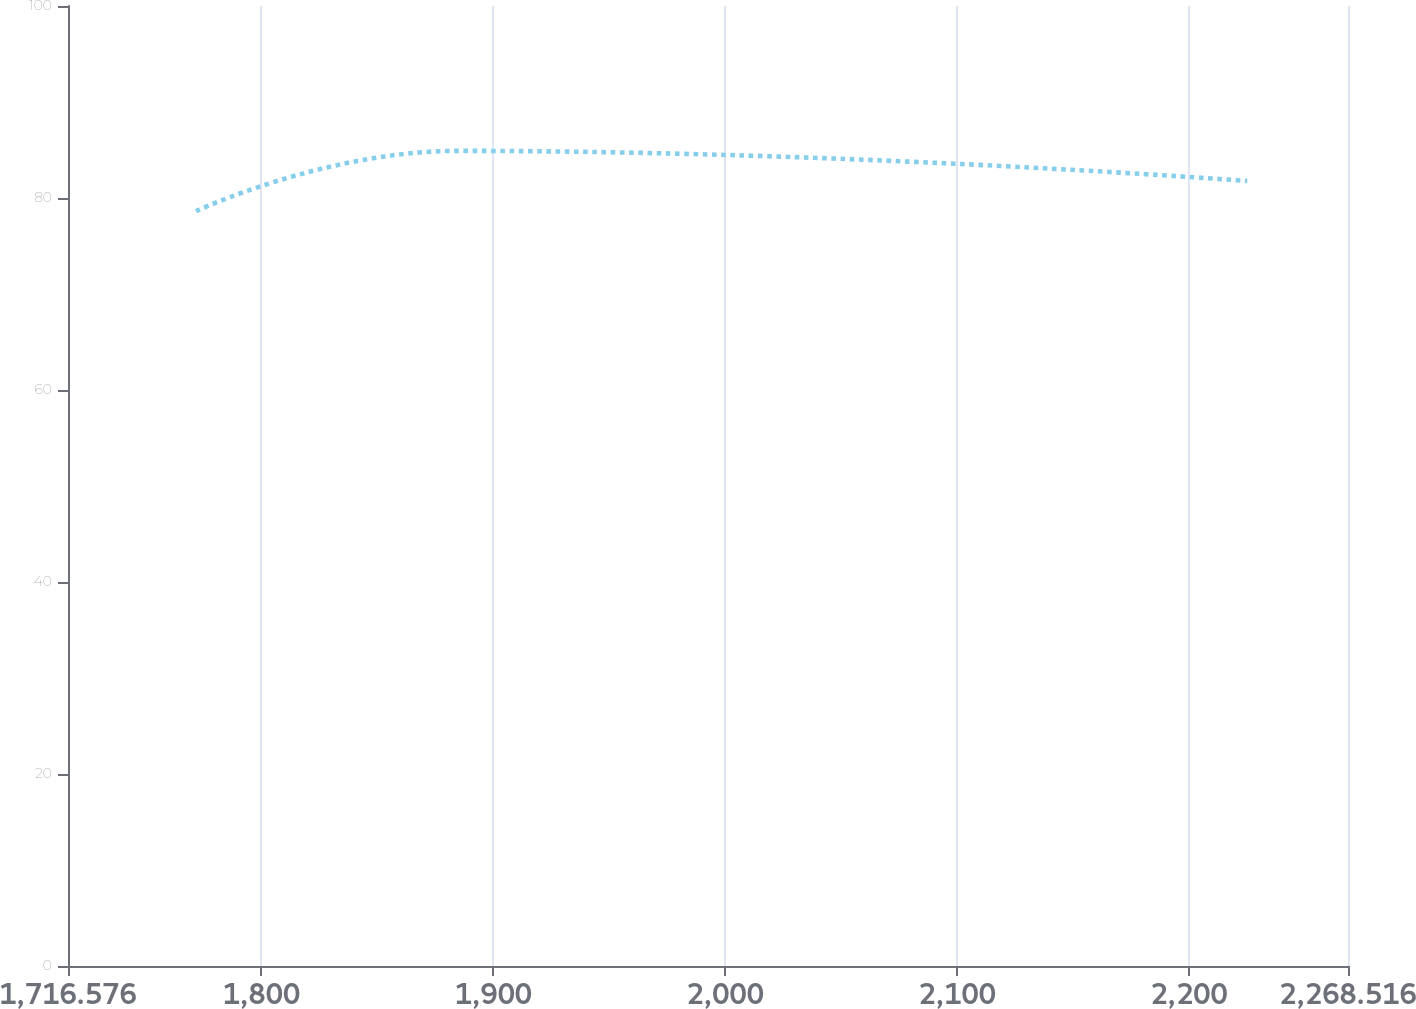<chart> <loc_0><loc_0><loc_500><loc_500><line_chart><ecel><fcel>Dollars in Millions<nl><fcel>1771.77<fcel>78.63<nl><fcel>1884.93<fcel>84.91<nl><fcel>2225.09<fcel>81.77<nl><fcel>2274.4<fcel>57.42<nl><fcel>2323.71<fcel>51.91<nl></chart> 